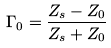<formula> <loc_0><loc_0><loc_500><loc_500>\Gamma _ { 0 } = \frac { Z _ { s } - Z _ { 0 } } { Z _ { s } + Z _ { 0 } }</formula> 